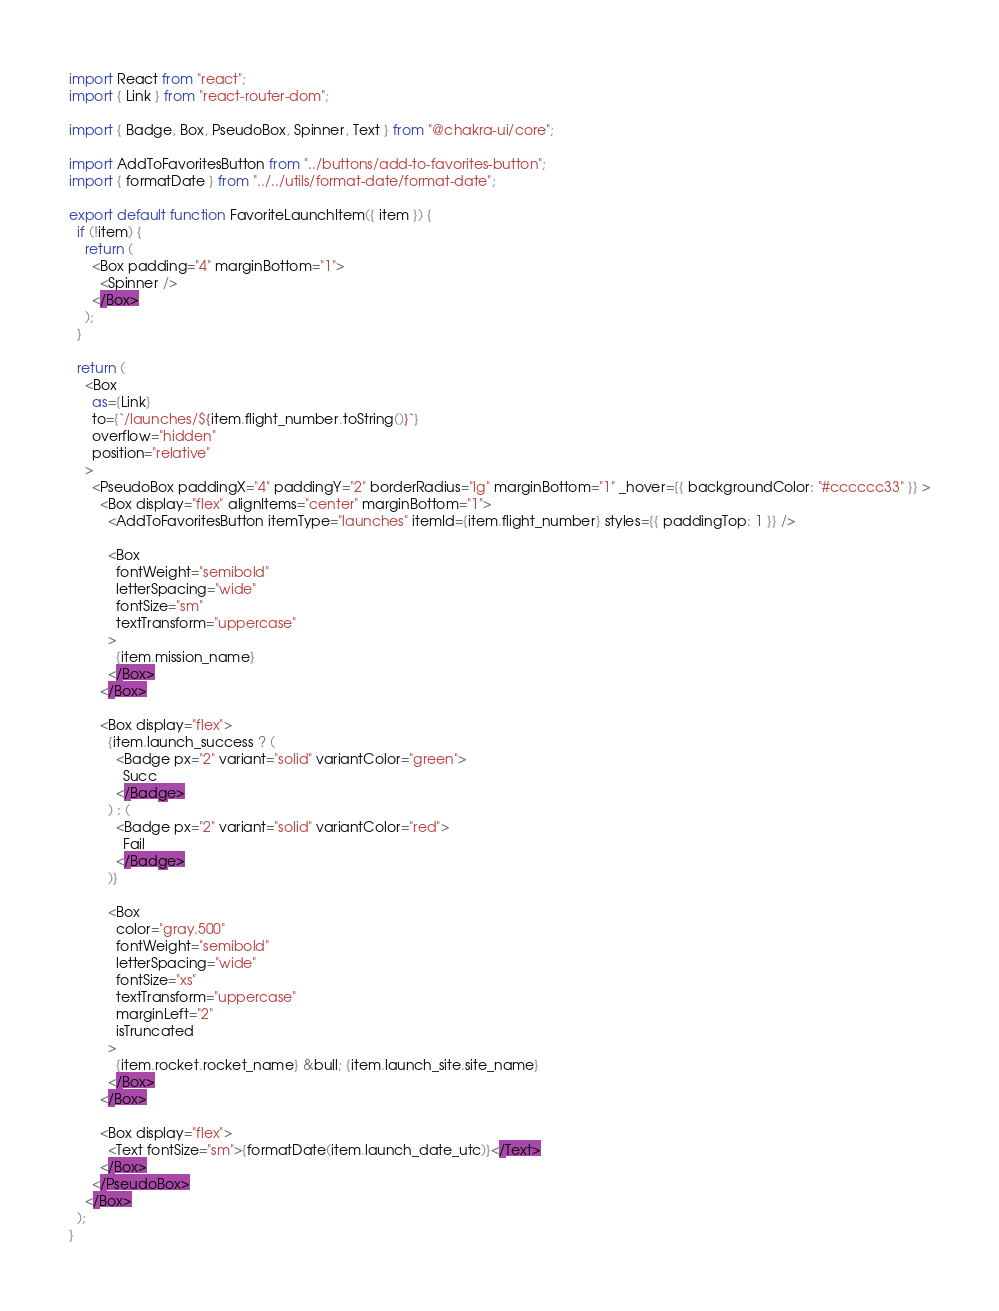Convert code to text. <code><loc_0><loc_0><loc_500><loc_500><_JavaScript_>import React from "react";
import { Link } from "react-router-dom";

import { Badge, Box, PseudoBox, Spinner, Text } from "@chakra-ui/core";

import AddToFavoritesButton from "../buttons/add-to-favorites-button";
import { formatDate } from "../../utils/format-date/format-date";

export default function FavoriteLaunchItem({ item }) {
  if (!item) {
    return (
      <Box padding="4" marginBottom="1">
        <Spinner />
      </Box>
    );
  }

  return (
    <Box
      as={Link}
      to={`/launches/${item.flight_number.toString()}`}
      overflow="hidden"
      position="relative"
    >
      <PseudoBox paddingX="4" paddingY="2" borderRadius="lg" marginBottom="1" _hover={{ backgroundColor: "#cccccc33" }} >
        <Box display="flex" alignItems="center" marginBottom="1">
          <AddToFavoritesButton itemType="launches" itemId={item.flight_number} styles={{ paddingTop: 1 }} />

          <Box
            fontWeight="semibold"
            letterSpacing="wide"
            fontSize="sm"
            textTransform="uppercase"
          >
            {item.mission_name}
          </Box>
        </Box>

        <Box display="flex">
          {item.launch_success ? (
            <Badge px="2" variant="solid" variantColor="green">
              Succ
            </Badge>
          ) : (
            <Badge px="2" variant="solid" variantColor="red">
              Fail
            </Badge>
          )}

          <Box
            color="gray.500"
            fontWeight="semibold"
            letterSpacing="wide"
            fontSize="xs"
            textTransform="uppercase"
            marginLeft="2"
            isTruncated
          >
            {item.rocket.rocket_name} &bull; {item.launch_site.site_name}
          </Box>
        </Box>

        <Box display="flex">
          <Text fontSize="sm">{formatDate(item.launch_date_utc)}</Text>
        </Box>
      </PseudoBox>
    </Box>
  );
}
</code> 